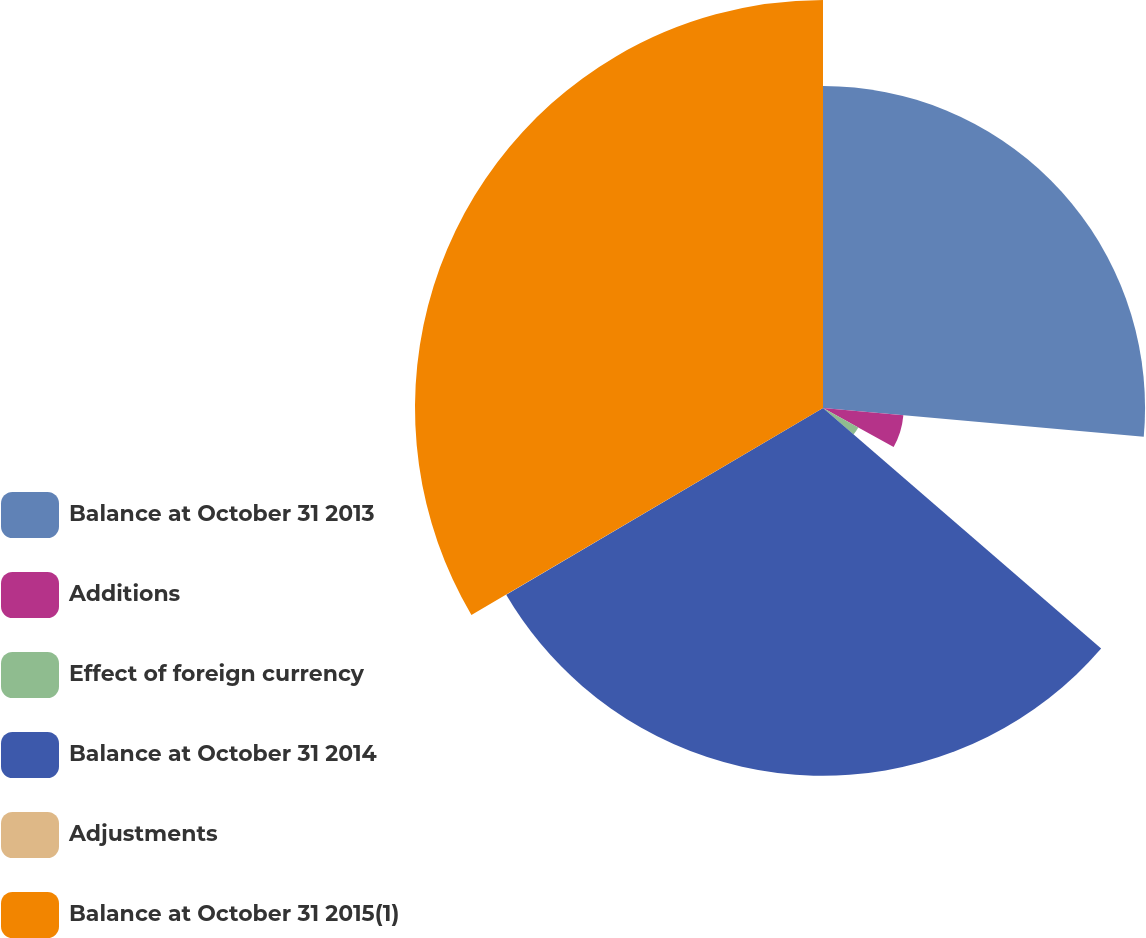Convert chart to OTSL. <chart><loc_0><loc_0><loc_500><loc_500><pie_chart><fcel>Balance at October 31 2013<fcel>Additions<fcel>Effect of foreign currency<fcel>Balance at October 31 2014<fcel>Adjustments<fcel>Balance at October 31 2015(1)<nl><fcel>26.42%<fcel>6.62%<fcel>3.31%<fcel>30.17%<fcel>0.01%<fcel>33.47%<nl></chart> 